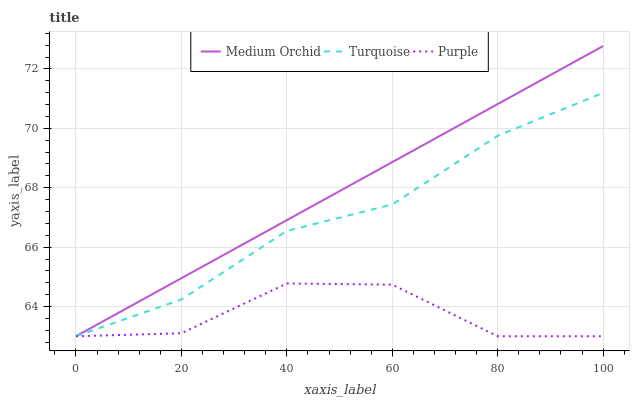Does Purple have the minimum area under the curve?
Answer yes or no. Yes. Does Medium Orchid have the maximum area under the curve?
Answer yes or no. Yes. Does Turquoise have the minimum area under the curve?
Answer yes or no. No. Does Turquoise have the maximum area under the curve?
Answer yes or no. No. Is Medium Orchid the smoothest?
Answer yes or no. Yes. Is Purple the roughest?
Answer yes or no. Yes. Is Turquoise the smoothest?
Answer yes or no. No. Is Turquoise the roughest?
Answer yes or no. No. Does Turquoise have the highest value?
Answer yes or no. No. 